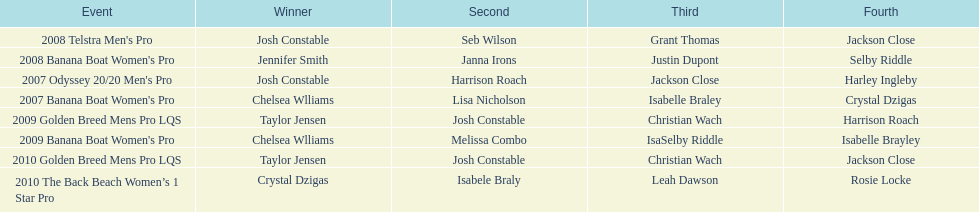How many times was josh constable the winner after 2007? 1. 